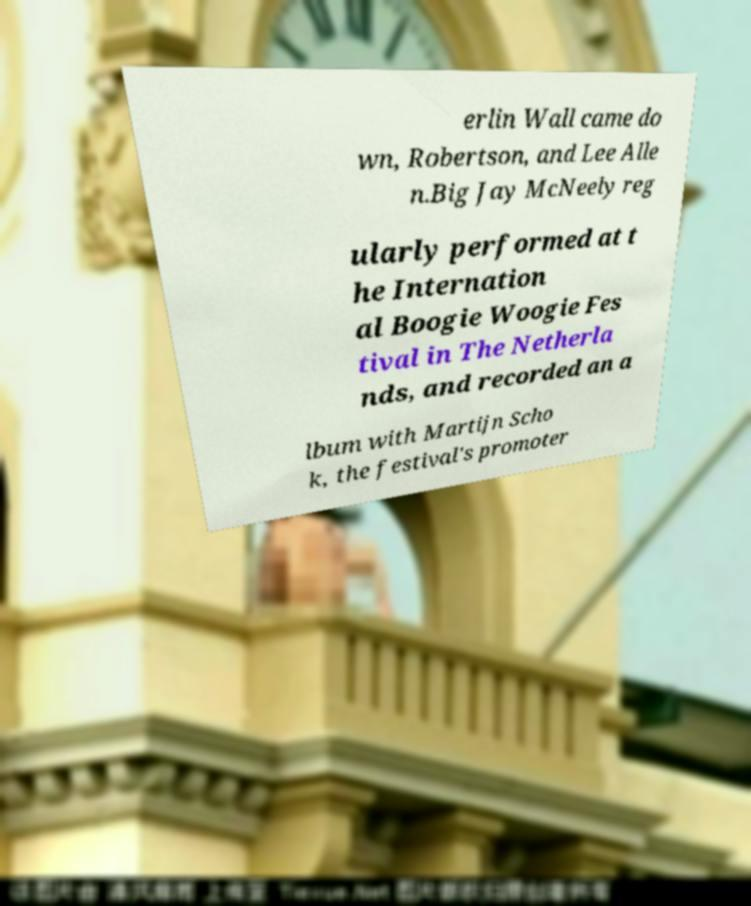Can you read and provide the text displayed in the image?This photo seems to have some interesting text. Can you extract and type it out for me? erlin Wall came do wn, Robertson, and Lee Alle n.Big Jay McNeely reg ularly performed at t he Internation al Boogie Woogie Fes tival in The Netherla nds, and recorded an a lbum with Martijn Scho k, the festival's promoter 